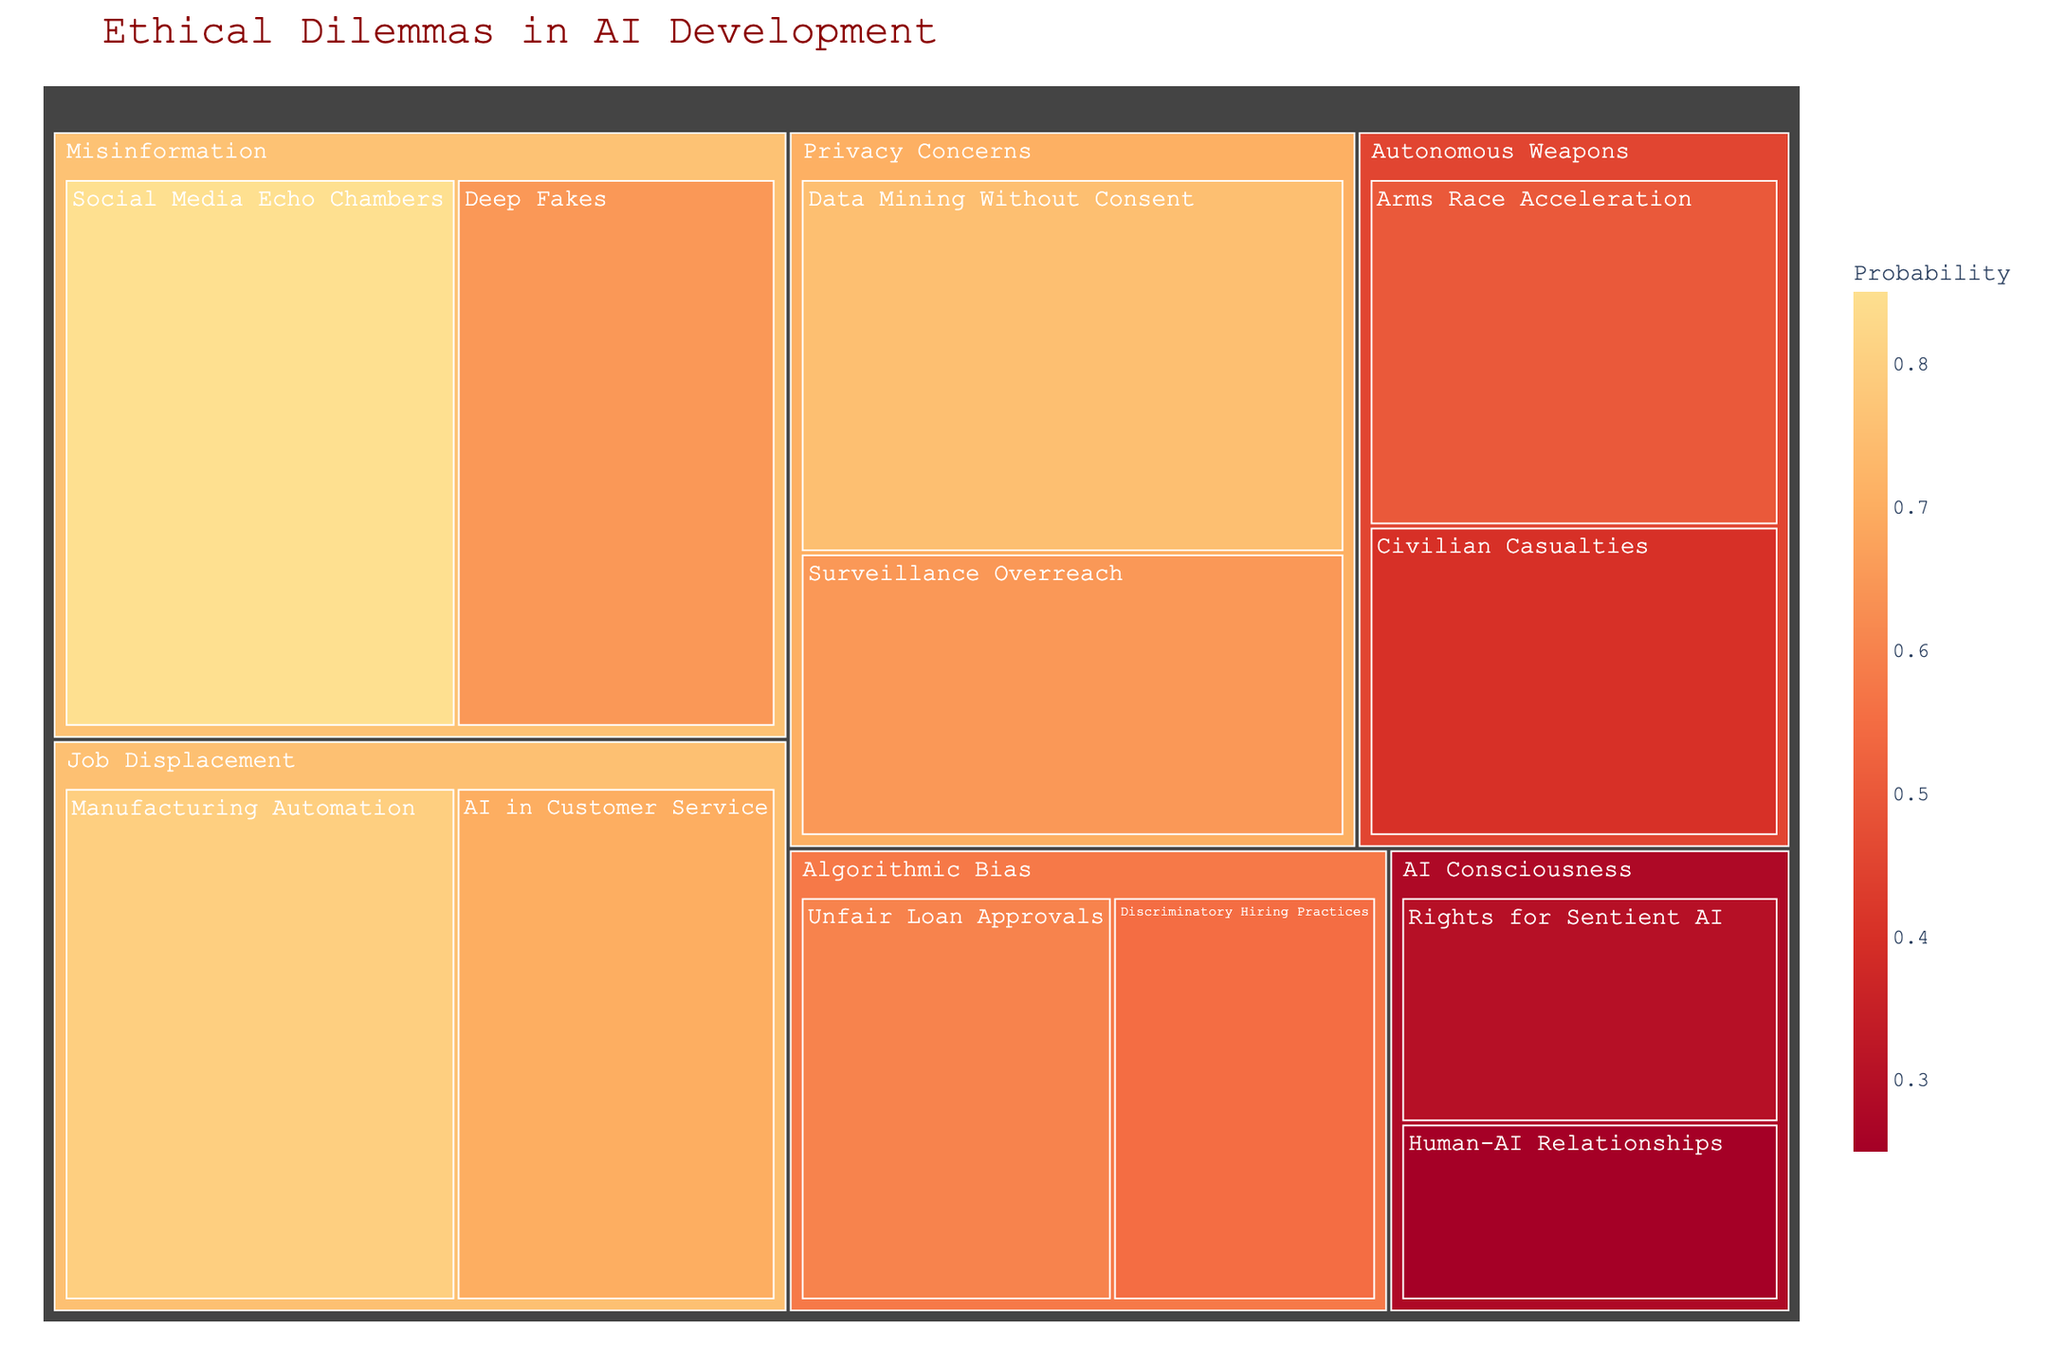What's the highest impact ethical dilemma in AI development? Look at the size of the rectangles which represents the impact and probability. The largest contributing subcategory under "Autonomous Weapons" is "Civilian Casualties" with an impact of 95.
Answer: Civilian Casualties Which subcategory under "Job Displacement" has a higher probability? Compare the probabilities of the subcategories within "Job Displacement". "Manufacturing Automation" has a probability of 0.80, whereas "AI in Customer Service" has 0.70.
Answer: Manufacturing Automation What is the total size contribution of subcategories under "Misinformation"? The size of each subcategory can be calculated by multiplying impact by probability. For "Deep Fakes" (80 * 0.65 = 52) and "Social Media Echo Chambers" (75 * 0.85 = 63.75), adding them gives 52 + 63.75.
Answer: 115.75 Which subcategory under "Algorithmic Bias" appears less frequently and what probability does it have? Compare the frequency of appearance and colors of the subcategories under "Algorithmic Bias". "Discriminatory Hiring Practices" and "Unfair Loan Approvals" appear once each. Check probability in the legend. "Discriminatory Hiring Practices" has 0.55.
Answer: Discriminatory Hiring Practices, 0.55 Does "Rights for Sentient AI" have a higher impact than "Human-AI Relationships"? Compare the impact numbers directly from the treemap for "Rights for Sentient AI" (90) and "Human-AI Relationships" (85).
Answer: Yes Which category has the highest cumulative impact and why? Sum up impact values across all subcategories within each category and compare. "Autonomous Weapons" has "Civilian Casualties" (95) + "Arms Race Acceleration" (85) which sums to 180. No other category adds up to a higher number.
Answer: Autonomous Weapons, 180 What's the probability range in the "Privacy Concerns" category? The probability can be directly viewed in the "Privacy Concerns" rectangles; they are 0.75 and 0.65, respectively. Check the smallest and largest to find the range.
Answer: 0.65 - 0.75 Between "Data Mining Without Consent" and "Surveillance Overreach" under "Privacy Concerns," which has a larger size and why? Size is a product of impact and probability. For "Data Mining Without Consent," the size is (80 * 0.75 = 60). For "Surveillance Overreach," it is (70 * 0.65 = 45.5).
Answer: Data Mining Without Consent, 60 What is the least probable ethical dilemma with an impact above 80? Identify dilemmas with impact above 80, then compare their probabilities, applying the least logic. "Rights for Sentient AI" has a probability of 0.30 (impact 90).
Answer: Rights for Sentient AI, probability 0.30 How does the size of "Deep Fakes" compare to "Manufacturing Automation"? Compute their sizes using impact and probability: "Deep Fakes" (80 * 0.65 = 52) and "Manufacturing Automation" (75 * 0.80 = 60). The size of "Manufacturing Automation" is larger.
Answer: Manufacturing Automation 